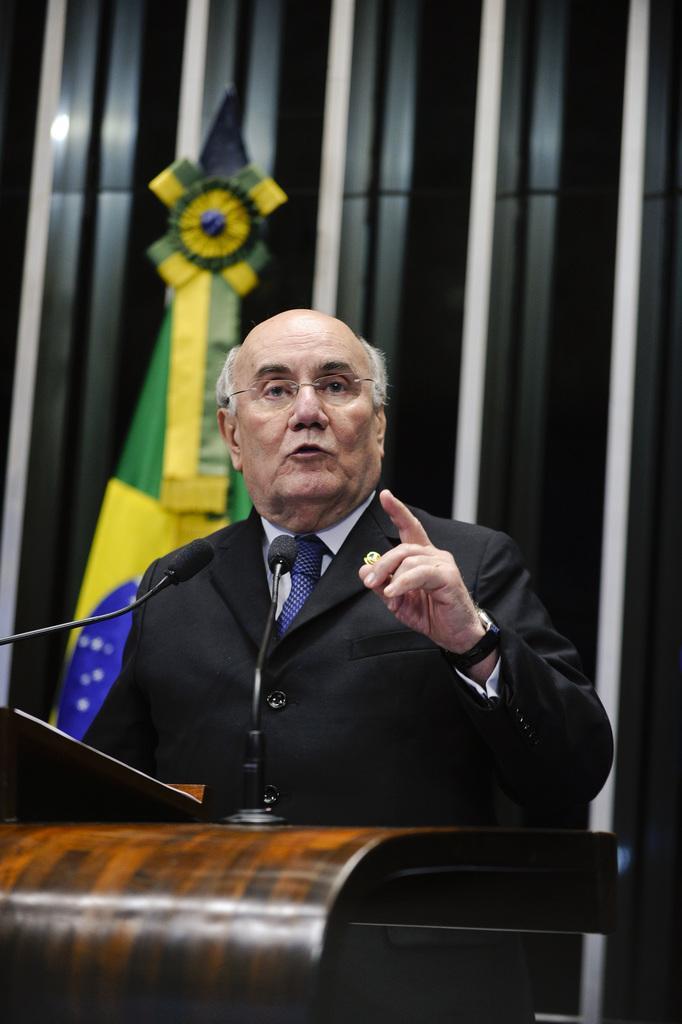Could you give a brief overview of what you see in this image? In this picture there is a man who is standing in the center of the image and there is a desk, a laptop, and mics in front of him, there is a flag in the background area of the image. 